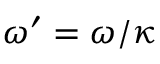<formula> <loc_0><loc_0><loc_500><loc_500>\omega ^ { \prime } = \omega / \kappa</formula> 